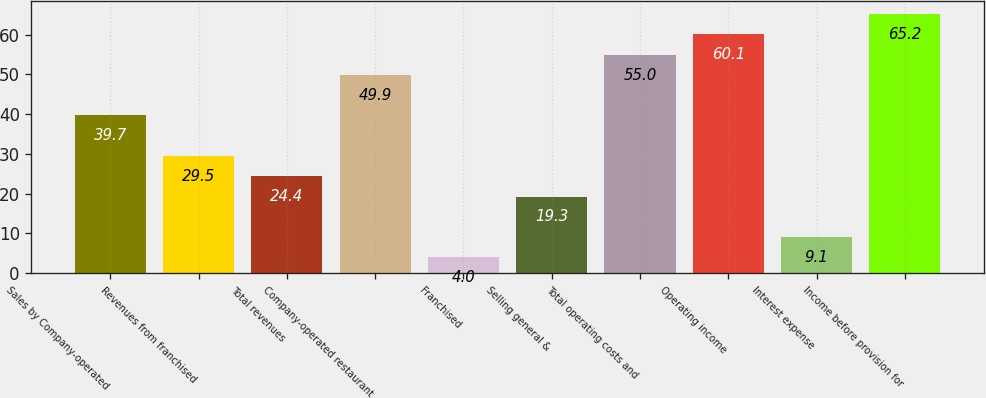<chart> <loc_0><loc_0><loc_500><loc_500><bar_chart><fcel>Sales by Company-operated<fcel>Revenues from franchised<fcel>Total revenues<fcel>Company-operated restaurant<fcel>Franchised<fcel>Selling general &<fcel>Total operating costs and<fcel>Operating income<fcel>Interest expense<fcel>Income before provision for<nl><fcel>39.7<fcel>29.5<fcel>24.4<fcel>49.9<fcel>4<fcel>19.3<fcel>55<fcel>60.1<fcel>9.1<fcel>65.2<nl></chart> 